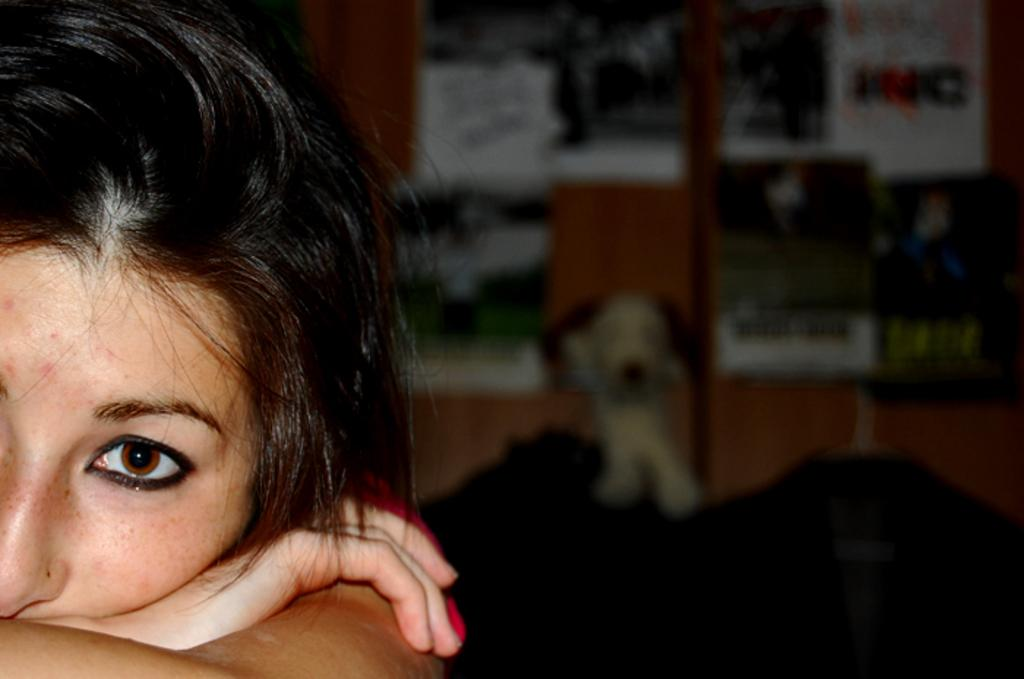What is present in the background of the image? There is a woman in the background of the image. Can you describe the appearance of the woman in the image? The woman is blurred in the image. Who is the creator of the root in the image? There is no root present in the image, so it is not possible to determine who its creator might be. 